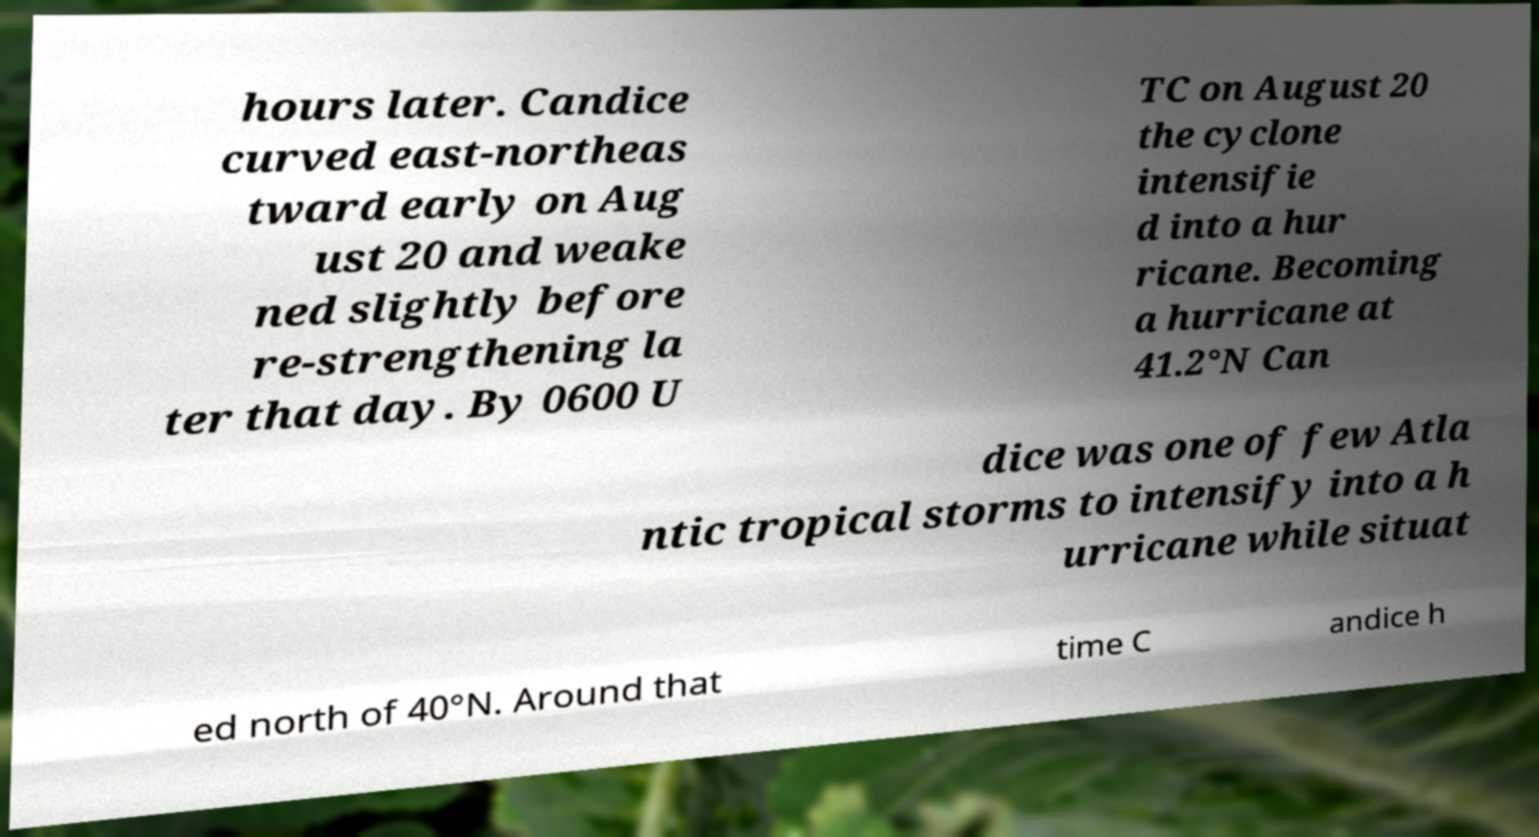Could you extract and type out the text from this image? hours later. Candice curved east-northeas tward early on Aug ust 20 and weake ned slightly before re-strengthening la ter that day. By 0600 U TC on August 20 the cyclone intensifie d into a hur ricane. Becoming a hurricane at 41.2°N Can dice was one of few Atla ntic tropical storms to intensify into a h urricane while situat ed north of 40°N. Around that time C andice h 